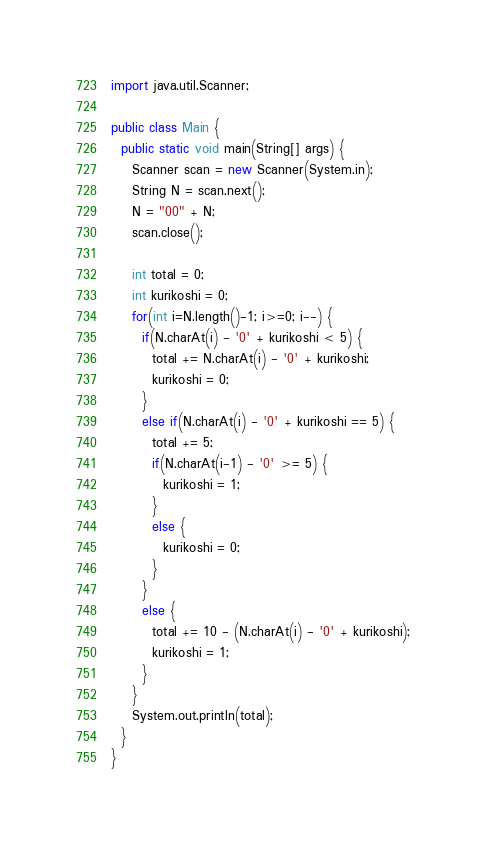<code> <loc_0><loc_0><loc_500><loc_500><_Java_>import java.util.Scanner;

public class Main {
  public static void main(String[] args) {
    Scanner scan = new Scanner(System.in);
    String N = scan.next();
    N = "00" + N;
    scan.close();

    int total = 0;
    int kurikoshi = 0;
    for(int i=N.length()-1; i>=0; i--) {
      if(N.charAt(i) - '0' + kurikoshi < 5) {
        total += N.charAt(i) - '0' + kurikoshi;
        kurikoshi = 0;
      }
      else if(N.charAt(i) - '0' + kurikoshi == 5) {
        total += 5;
        if(N.charAt(i-1) - '0' >= 5) {
          kurikoshi = 1;
        }
        else {
          kurikoshi = 0;
        }
      }
      else {
        total += 10 - (N.charAt(i) - '0' + kurikoshi);
        kurikoshi = 1;
      }
    }
    System.out.println(total);
  }
}</code> 